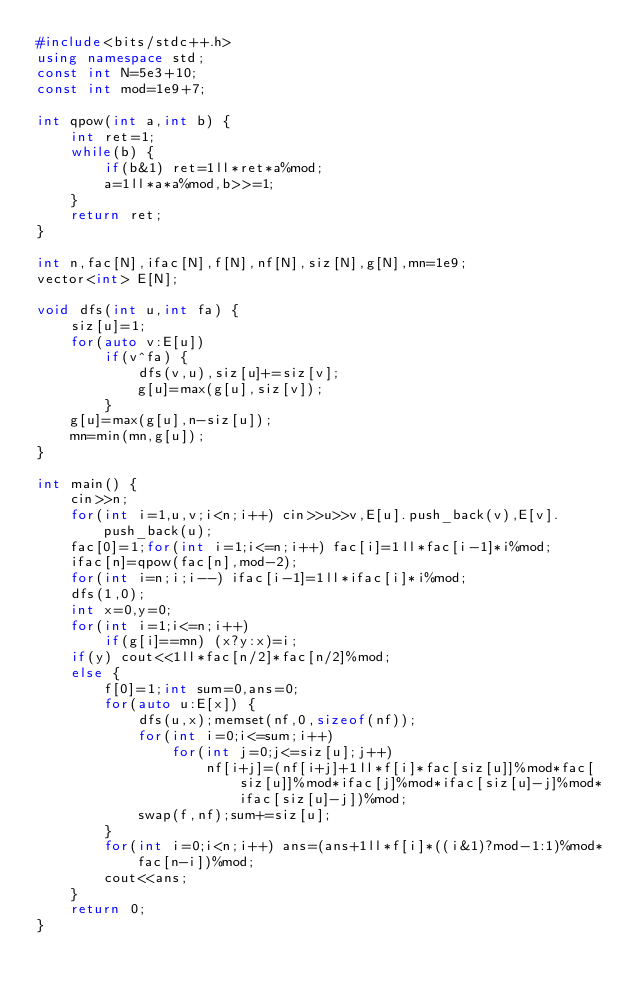Convert code to text. <code><loc_0><loc_0><loc_500><loc_500><_C++_>#include<bits/stdc++.h>
using namespace std;
const int N=5e3+10;
const int mod=1e9+7;

int qpow(int a,int b) {
	int ret=1;
	while(b) {
		if(b&1) ret=1ll*ret*a%mod;
		a=1ll*a*a%mod,b>>=1;
	}
	return ret;
}

int n,fac[N],ifac[N],f[N],nf[N],siz[N],g[N],mn=1e9;
vector<int> E[N];

void dfs(int u,int fa) {
	siz[u]=1;
	for(auto v:E[u])
		if(v^fa) {
			dfs(v,u),siz[u]+=siz[v];
			g[u]=max(g[u],siz[v]);
		}
	g[u]=max(g[u],n-siz[u]);
	mn=min(mn,g[u]);
}

int main() {
	cin>>n;
	for(int i=1,u,v;i<n;i++) cin>>u>>v,E[u].push_back(v),E[v].push_back(u);
	fac[0]=1;for(int i=1;i<=n;i++) fac[i]=1ll*fac[i-1]*i%mod;
	ifac[n]=qpow(fac[n],mod-2);
	for(int i=n;i;i--) ifac[i-1]=1ll*ifac[i]*i%mod;
	dfs(1,0);
	int x=0,y=0;
	for(int i=1;i<=n;i++)
		if(g[i]==mn) (x?y:x)=i;
	if(y) cout<<1ll*fac[n/2]*fac[n/2]%mod;
	else {
		f[0]=1;int sum=0,ans=0;
		for(auto u:E[x]) {
			dfs(u,x);memset(nf,0,sizeof(nf));
			for(int i=0;i<=sum;i++)
				for(int j=0;j<=siz[u];j++)
					nf[i+j]=(nf[i+j]+1ll*f[i]*fac[siz[u]]%mod*fac[siz[u]]%mod*ifac[j]%mod*ifac[siz[u]-j]%mod*ifac[siz[u]-j])%mod;
			swap(f,nf);sum+=siz[u];
		}
		for(int i=0;i<n;i++) ans=(ans+1ll*f[i]*((i&1)?mod-1:1)%mod*fac[n-i])%mod;
		cout<<ans;
	}
	return 0;
}
</code> 